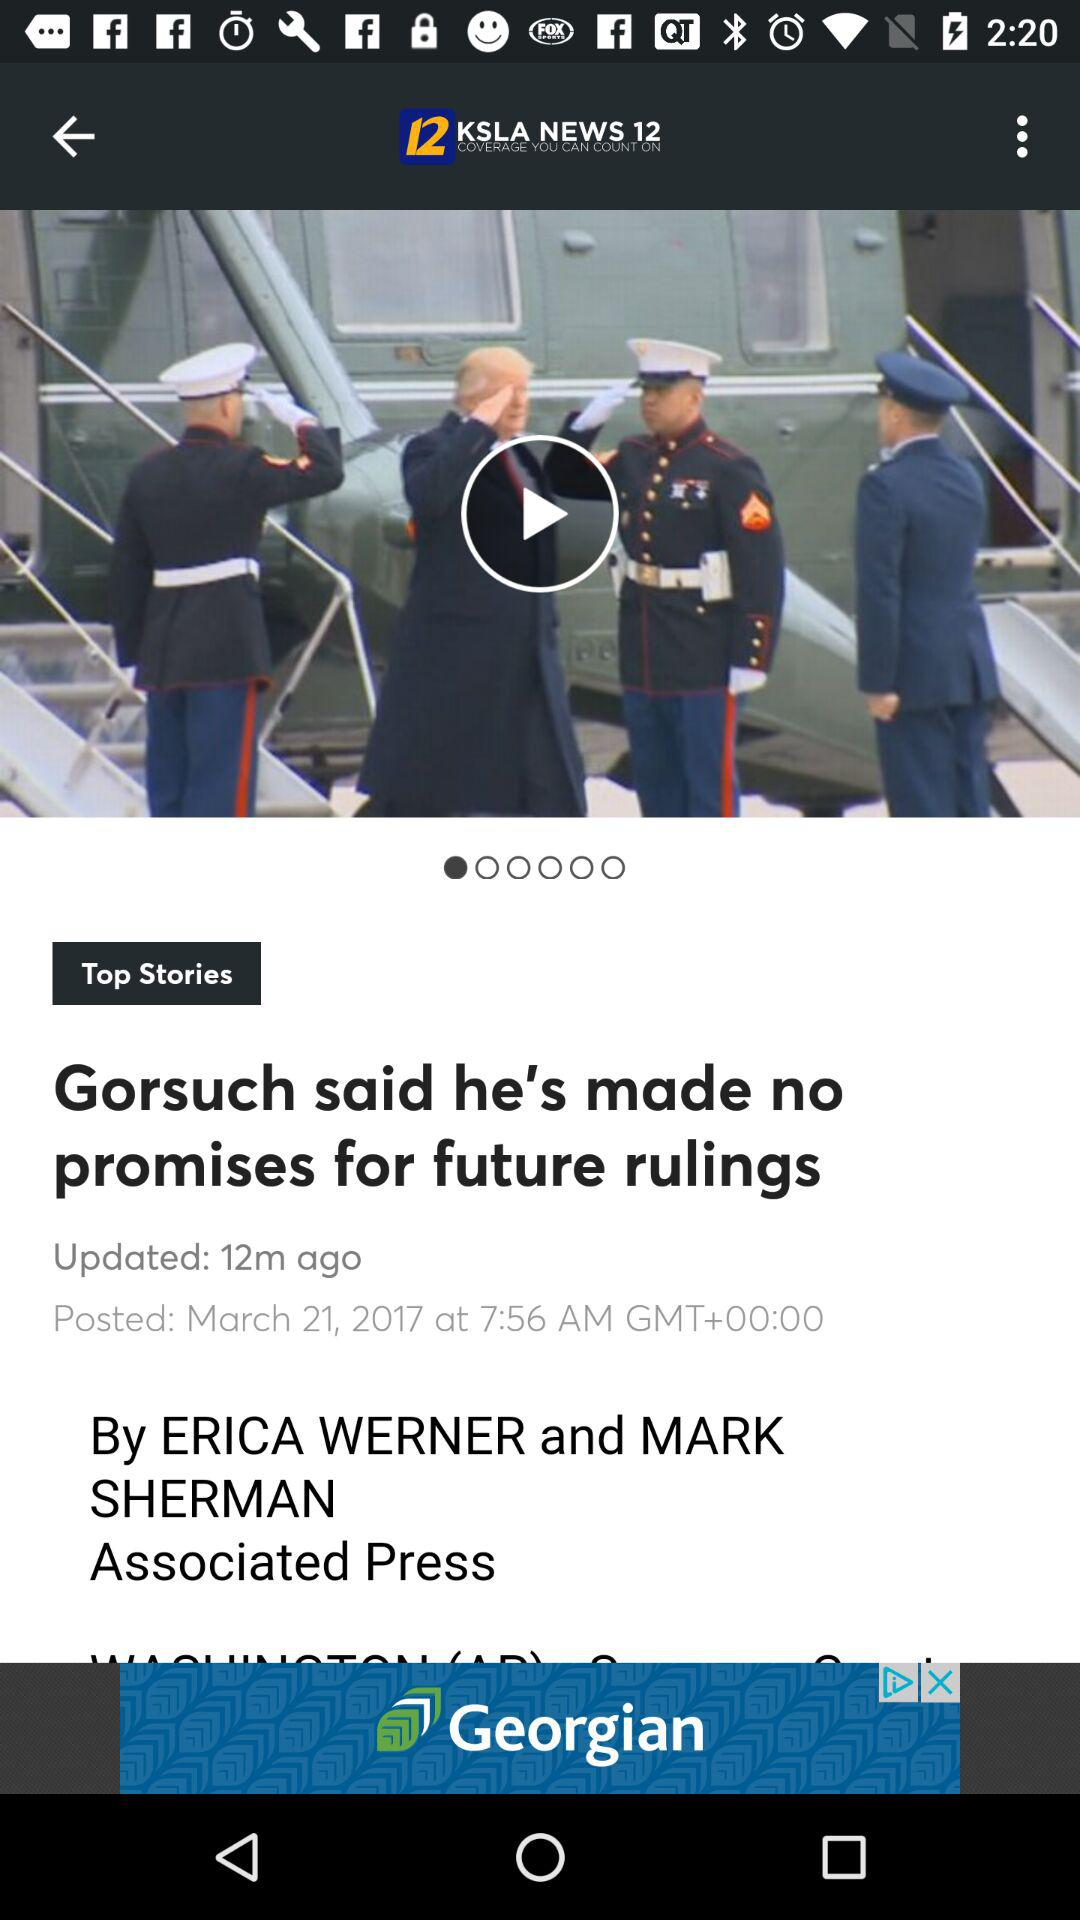When was the article updated? The article was updated 12 minutes ago. 